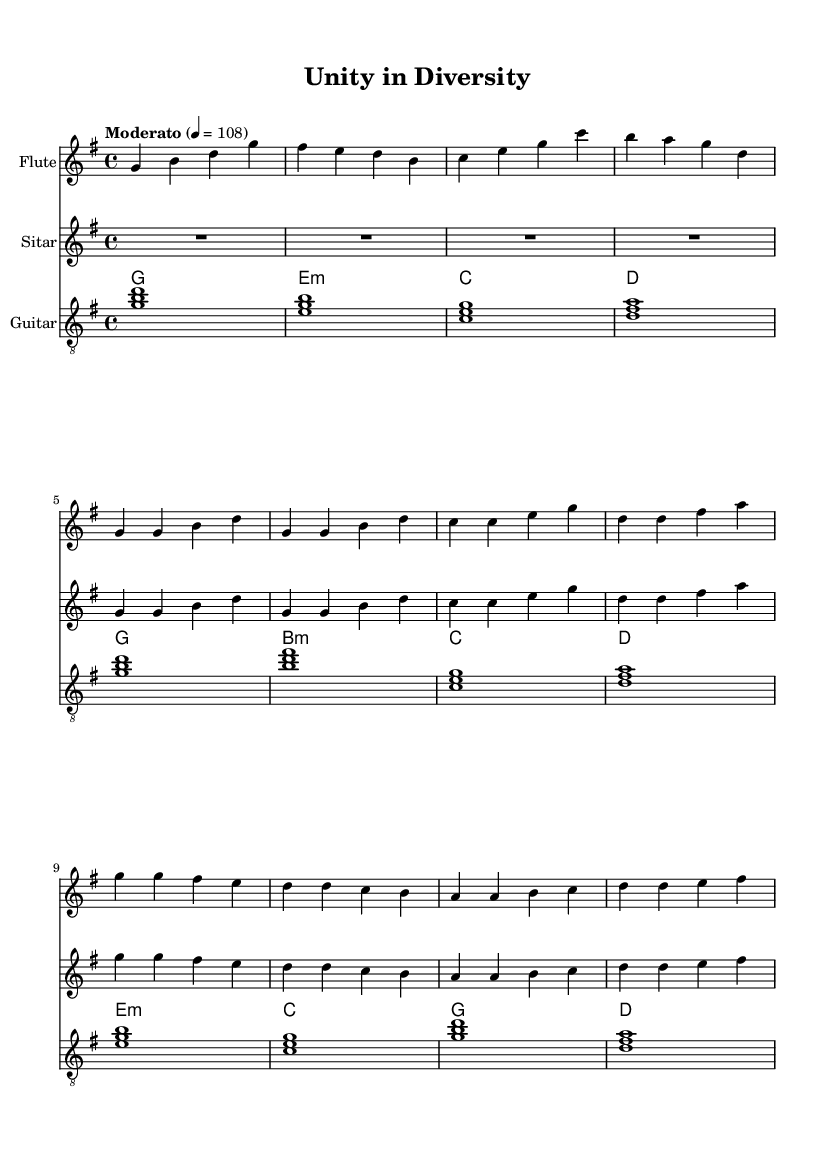What is the key signature of this music? The key signature is G major, which has one sharp (F#).
Answer: G major What is the time signature of the piece? The time signature is 4/4, indicating that there are four beats in each measure.
Answer: 4/4 What is the tempo marking for this piece? The tempo marking is "Moderato" indicating a moderate speed, with a metronome marking of 108 beats per minute.
Answer: Moderato How many instruments are written in this score? There are four instruments notated: Flute, Sitar, Guitar, and Chord Names for guitar.
Answer: Four What is the first note played by the flute? The first note played by the flute is G.
Answer: G Which chord is played in the first measure by the guitar? The first measure features a G major chord, which is formed from the notes G, B, and D.
Answer: G major How does the music represent cultural diversity? The music fuses traditional Western flute with Eastern sitar, showcasing the blend of different musical cultures.
Answer: Fusion of cultures 